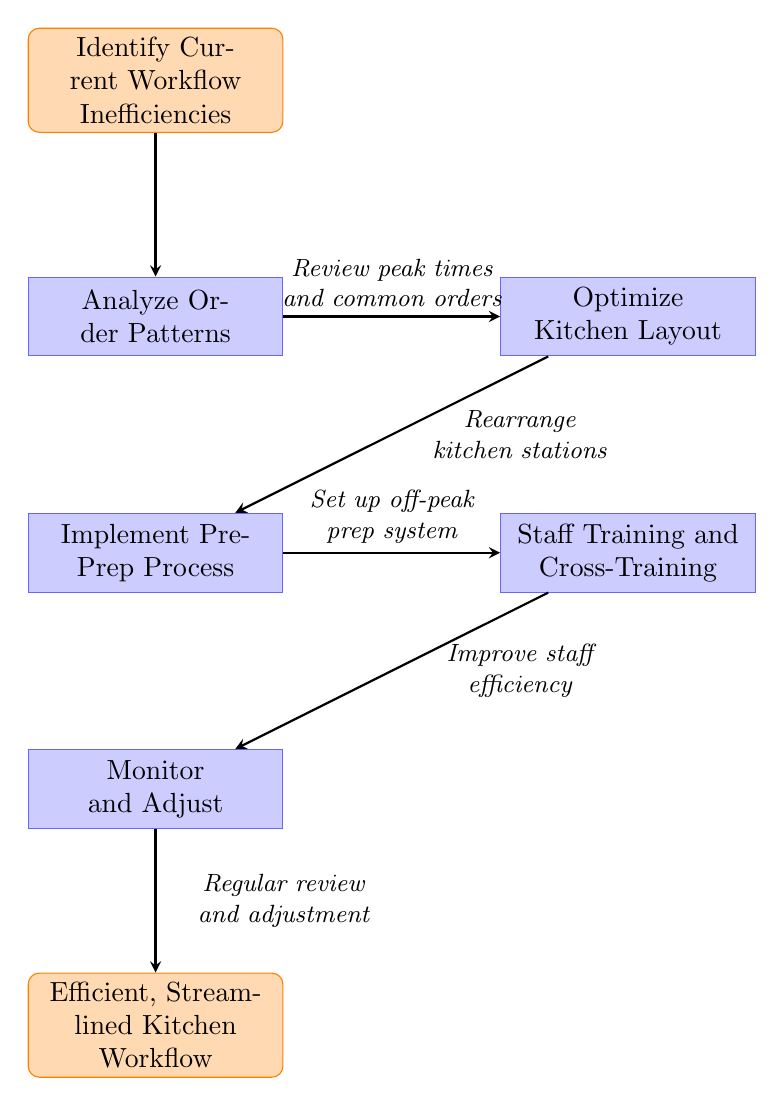What is the first step in the workflow? The first step in the workflow, depicted at the top of the diagram, is "Identify Current Workflow Inefficiencies".
Answer: Identify Current Workflow Inefficiencies How many nodes are there in the diagram? Counting the nodes, we can identify six distinct steps: the start node, five process nodes, and the end node. Therefore, there are six nodes in total.
Answer: 6 What step comes after "Analyze Order Patterns"? The step that follows "Analyze Order Patterns" is "Optimize Kitchen Layout", which is directly to the right of it in the diagram.
Answer: Optimize Kitchen Layout What does the "Implement Pre-Prep Process" step focus on? This step focuses on setting up a system for prepping ingredients during off-peak hours, as described in the diagram.
Answer: Set up a system for prepping ingredients during off-peak hours What is the last step in the diagram? The last step in the diagram is "Efficient, Streamlined Kitchen Workflow", which concludes the workflow process.
Answer: Efficient, Streamlined Kitchen Workflow What relationship exists between "Optimize Kitchen Layout" and "Implement Pre-Prep Process"? The relationship is sequential; "Optimize Kitchen Layout" is a step that leads directly into "Implement Pre-Prep Process", indicating that optimizing the layout should occur before implementing the pre-prep process.
Answer: Sequential relationship What action is suggested in the "Staff Training and Cross-Training" node? This node suggests training staff to handle multiple stations, which aims to improve efficiency in the kitchen workflow.
Answer: Train staff to handle multiple stations How does "Monitor and Adjust" relate to the other steps? "Monitor and Adjust" occurs at the end of the sequence and involves regularly reviewing the workflow to implement necessary adjustments based on the previous steps' outcomes.
Answer: Regularly review the workflow and make necessary adjustments 